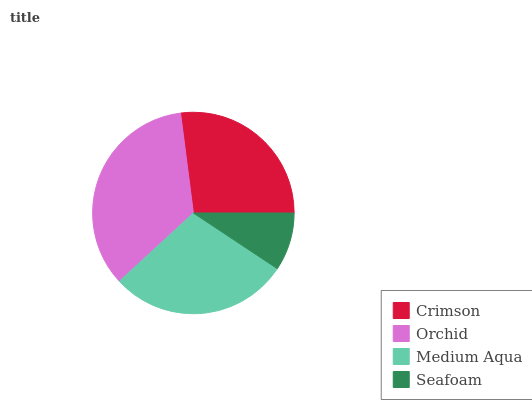Is Seafoam the minimum?
Answer yes or no. Yes. Is Orchid the maximum?
Answer yes or no. Yes. Is Medium Aqua the minimum?
Answer yes or no. No. Is Medium Aqua the maximum?
Answer yes or no. No. Is Orchid greater than Medium Aqua?
Answer yes or no. Yes. Is Medium Aqua less than Orchid?
Answer yes or no. Yes. Is Medium Aqua greater than Orchid?
Answer yes or no. No. Is Orchid less than Medium Aqua?
Answer yes or no. No. Is Medium Aqua the high median?
Answer yes or no. Yes. Is Crimson the low median?
Answer yes or no. Yes. Is Seafoam the high median?
Answer yes or no. No. Is Orchid the low median?
Answer yes or no. No. 